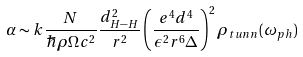Convert formula to latex. <formula><loc_0><loc_0><loc_500><loc_500>\alpha \sim k \frac { N } { \hbar { \rho } \Omega c ^ { 2 } } \frac { d _ { H - H } ^ { 2 } } { r ^ { 2 } } \left ( \frac { e ^ { 4 } d ^ { 4 } } { \epsilon ^ { 2 } r ^ { 6 } \Delta } \right ) ^ { 2 } \rho _ { t u n n } ( \omega _ { p h } )</formula> 